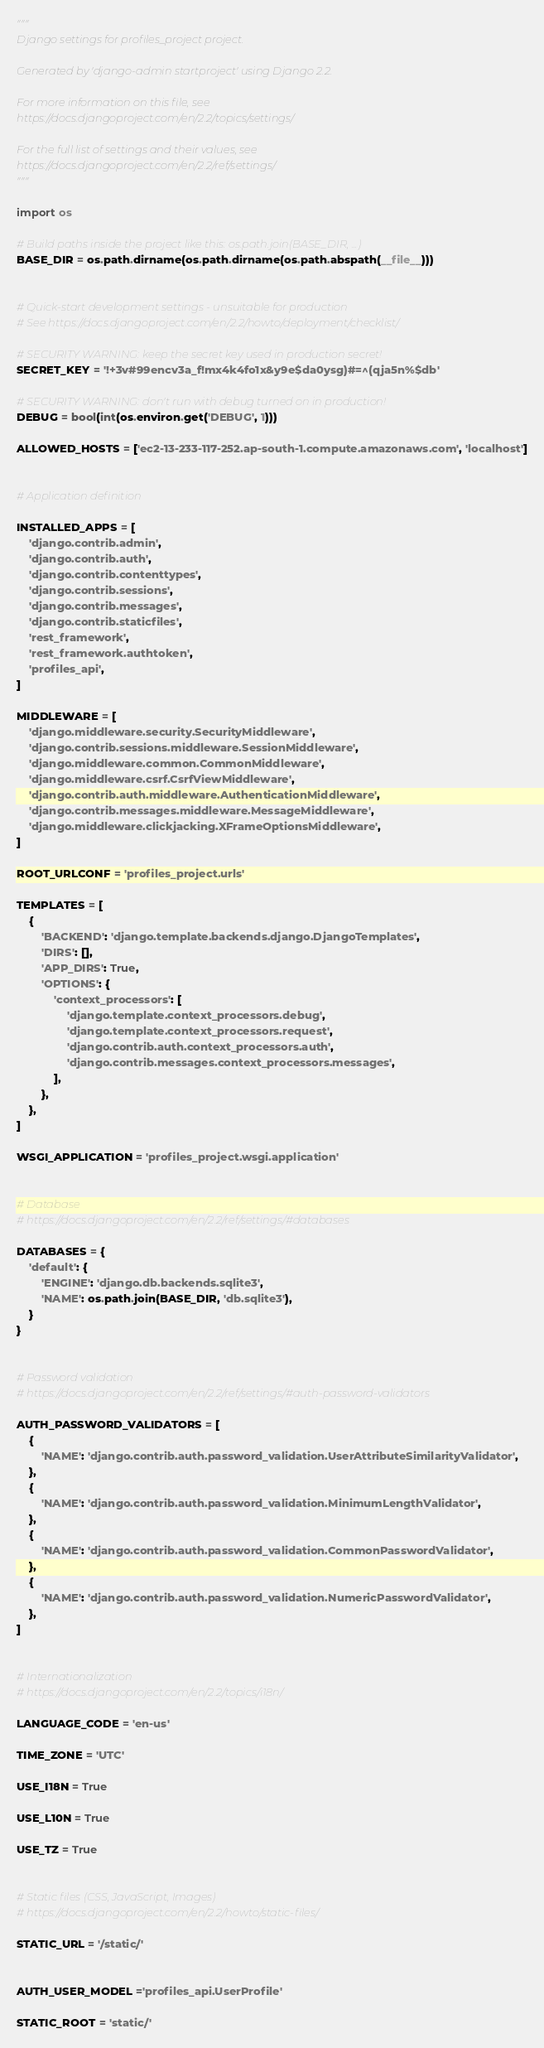<code> <loc_0><loc_0><loc_500><loc_500><_Python_>"""
Django settings for profiles_project project.

Generated by 'django-admin startproject' using Django 2.2.

For more information on this file, see
https://docs.djangoproject.com/en/2.2/topics/settings/

For the full list of settings and their values, see
https://docs.djangoproject.com/en/2.2/ref/settings/
"""

import os

# Build paths inside the project like this: os.path.join(BASE_DIR, ...)
BASE_DIR = os.path.dirname(os.path.dirname(os.path.abspath(__file__)))


# Quick-start development settings - unsuitable for production
# See https://docs.djangoproject.com/en/2.2/howto/deployment/checklist/

# SECURITY WARNING: keep the secret key used in production secret!
SECRET_KEY = '!+3v#99encv3a_f!mx4k4fo1x&y9e$da0ysg)#=^(qja5n%$db'

# SECURITY WARNING: don't run with debug turned on in production!
DEBUG = bool(int(os.environ.get('DEBUG', 1)))

ALLOWED_HOSTS = ['ec2-13-233-117-252.ap-south-1.compute.amazonaws.com', 'localhost']


# Application definition

INSTALLED_APPS = [
    'django.contrib.admin',
    'django.contrib.auth',
    'django.contrib.contenttypes',
    'django.contrib.sessions',
    'django.contrib.messages',
    'django.contrib.staticfiles',
    'rest_framework',
    'rest_framework.authtoken',
    'profiles_api',
]

MIDDLEWARE = [
    'django.middleware.security.SecurityMiddleware',
    'django.contrib.sessions.middleware.SessionMiddleware',
    'django.middleware.common.CommonMiddleware',
    'django.middleware.csrf.CsrfViewMiddleware',
    'django.contrib.auth.middleware.AuthenticationMiddleware',
    'django.contrib.messages.middleware.MessageMiddleware',
    'django.middleware.clickjacking.XFrameOptionsMiddleware',
]

ROOT_URLCONF = 'profiles_project.urls'

TEMPLATES = [
    {
        'BACKEND': 'django.template.backends.django.DjangoTemplates',
        'DIRS': [],
        'APP_DIRS': True,
        'OPTIONS': {
            'context_processors': [
                'django.template.context_processors.debug',
                'django.template.context_processors.request',
                'django.contrib.auth.context_processors.auth',
                'django.contrib.messages.context_processors.messages',
            ],
        },
    },
]

WSGI_APPLICATION = 'profiles_project.wsgi.application'


# Database
# https://docs.djangoproject.com/en/2.2/ref/settings/#databases

DATABASES = {
    'default': {
        'ENGINE': 'django.db.backends.sqlite3',
        'NAME': os.path.join(BASE_DIR, 'db.sqlite3'),
    }
}


# Password validation
# https://docs.djangoproject.com/en/2.2/ref/settings/#auth-password-validators

AUTH_PASSWORD_VALIDATORS = [
    {
        'NAME': 'django.contrib.auth.password_validation.UserAttributeSimilarityValidator',
    },
    {
        'NAME': 'django.contrib.auth.password_validation.MinimumLengthValidator',
    },
    {
        'NAME': 'django.contrib.auth.password_validation.CommonPasswordValidator',
    },
    {
        'NAME': 'django.contrib.auth.password_validation.NumericPasswordValidator',
    },
]


# Internationalization
# https://docs.djangoproject.com/en/2.2/topics/i18n/

LANGUAGE_CODE = 'en-us'

TIME_ZONE = 'UTC'

USE_I18N = True

USE_L10N = True

USE_TZ = True


# Static files (CSS, JavaScript, Images)
# https://docs.djangoproject.com/en/2.2/howto/static-files/

STATIC_URL = '/static/'


AUTH_USER_MODEL ='profiles_api.UserProfile'

STATIC_ROOT = 'static/'
</code> 